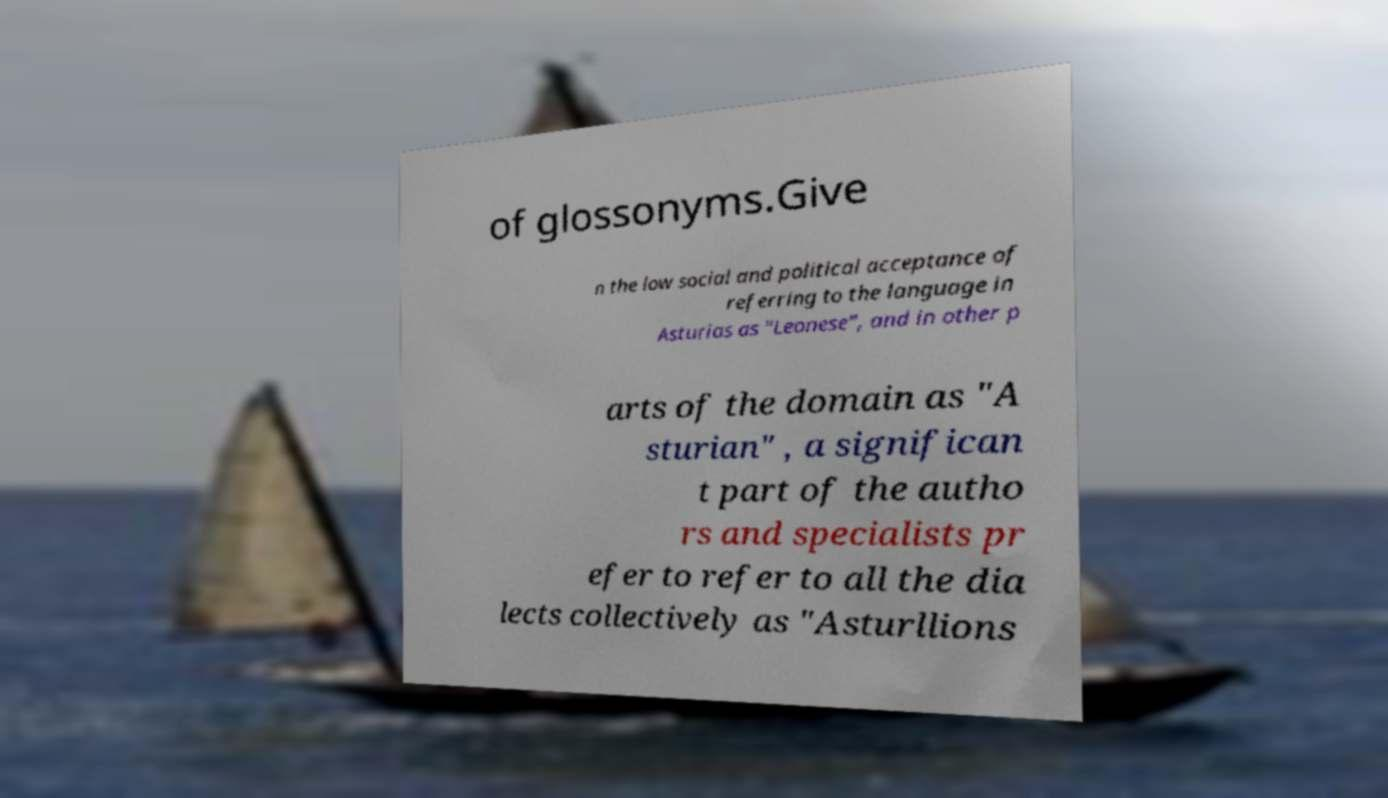Can you read and provide the text displayed in the image?This photo seems to have some interesting text. Can you extract and type it out for me? of glossonyms.Give n the low social and political acceptance of referring to the language in Asturias as "Leonese", and in other p arts of the domain as "A sturian" , a significan t part of the autho rs and specialists pr efer to refer to all the dia lects collectively as "Asturllions 